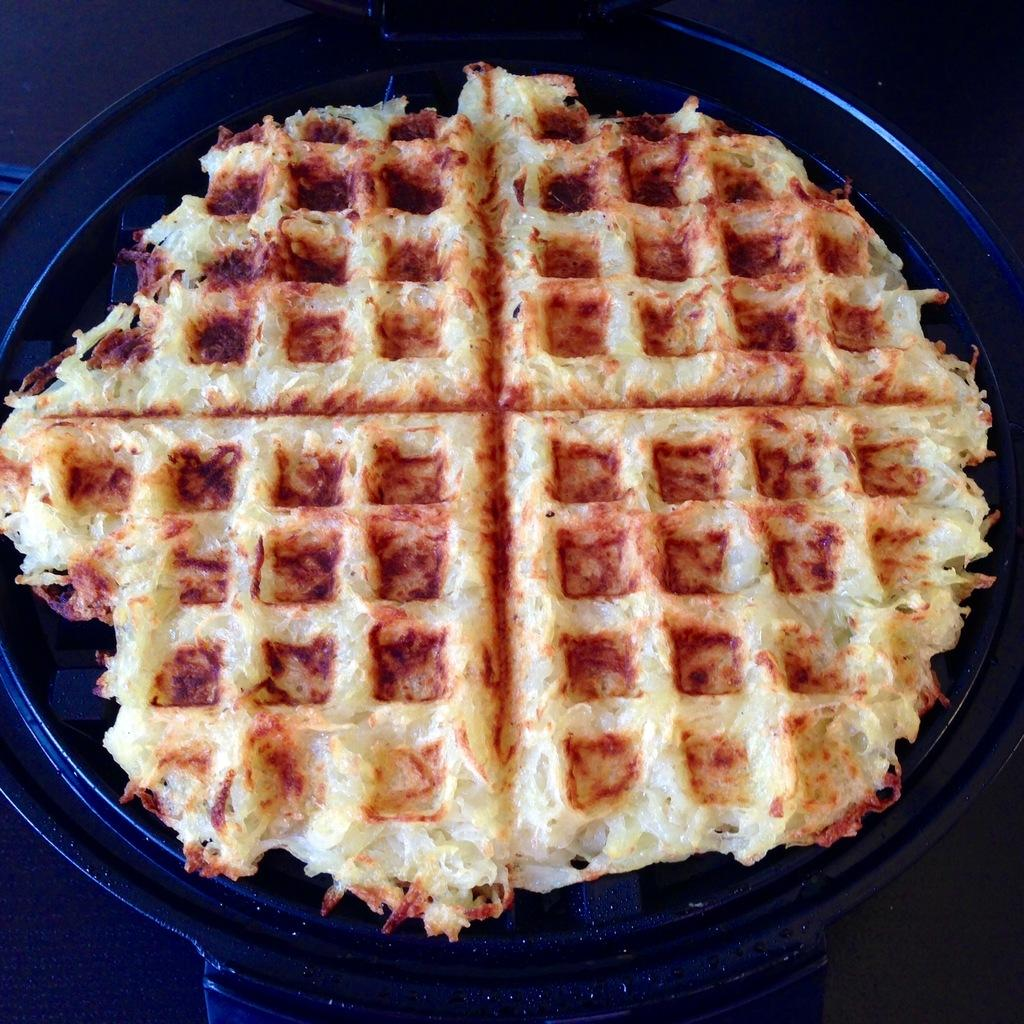What object is present in the image that is typically used for cooking? There is a pan in the image. What is inside the pan? The pan contains food. Can you describe the appearance of the food in the pan? The food has red and cream colors. Are there any fairies flying around the pan in the image? No, there are no fairies present in the image. Is there a gate visible in the image? No, there is no gate visible in the image. 